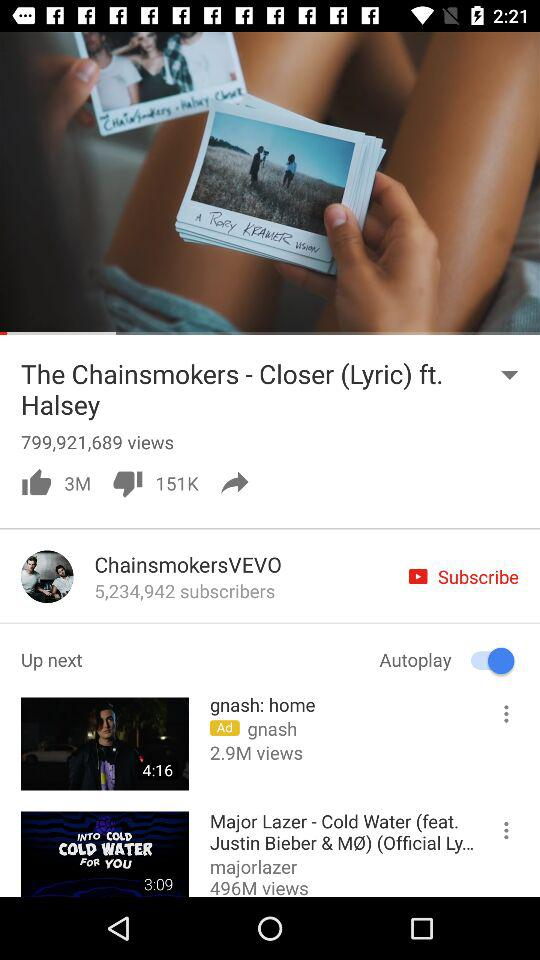How many people have subscribed to "ChainsmokersVEVO"? There are 5,234,942 people who have subscribed. 